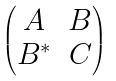<formula> <loc_0><loc_0><loc_500><loc_500>\begin{pmatrix} A & B \\ B ^ { * } & C \end{pmatrix}</formula> 